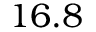Convert formula to latex. <formula><loc_0><loc_0><loc_500><loc_500>1 6 . 8</formula> 